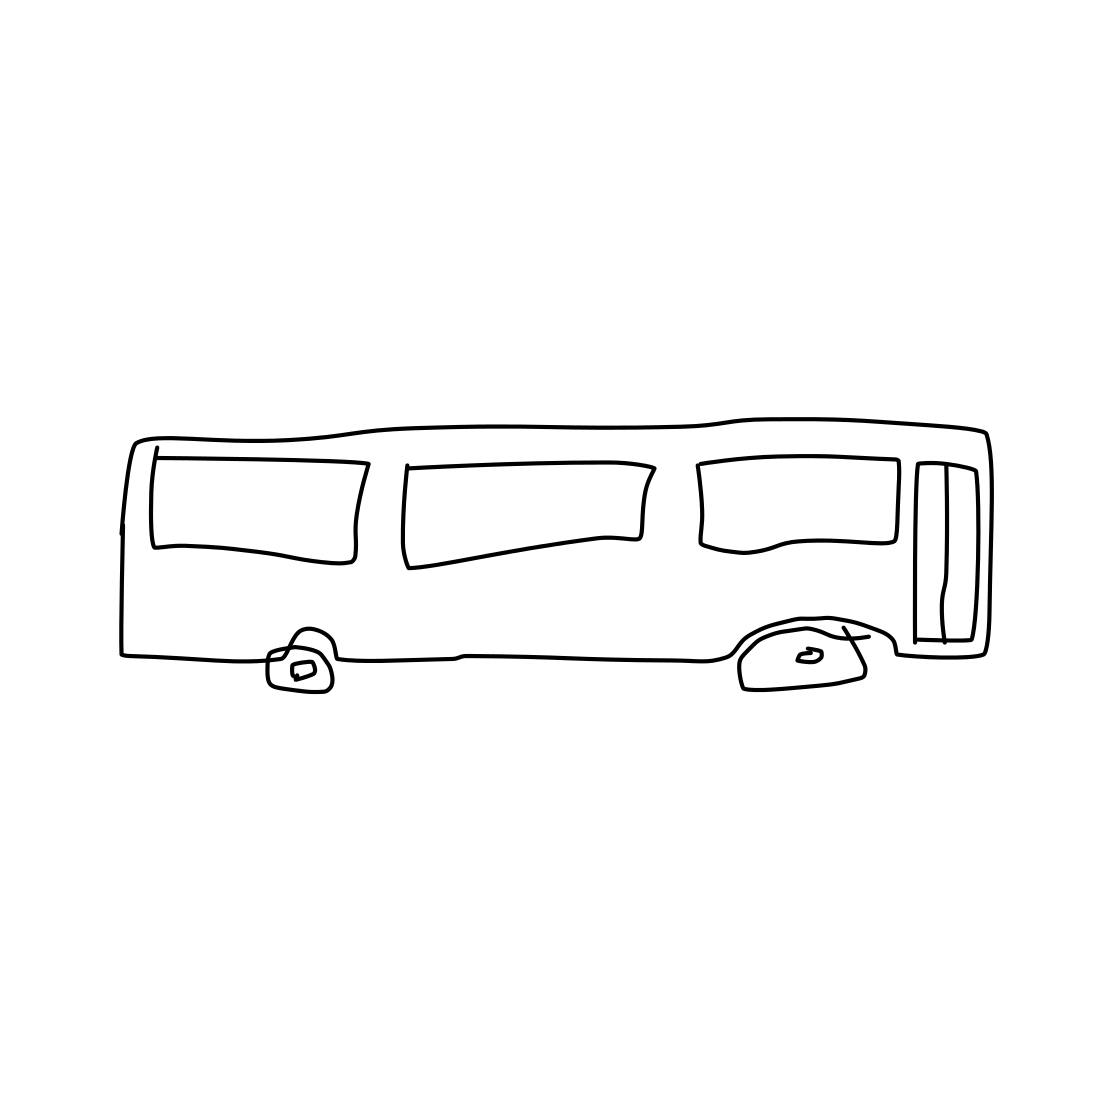Is there a sketchy mushroom in the picture? I've carefully inspected the image and can confirm that there is no depiction of a mushroom, sketchy or otherwise. What the image actually shows is a simplified line drawing of a side view of a bus. 